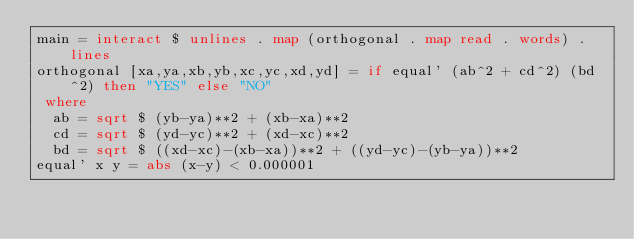Convert code to text. <code><loc_0><loc_0><loc_500><loc_500><_Haskell_>main = interact $ unlines . map (orthogonal . map read . words) . lines
orthogonal [xa,ya,xb,yb,xc,yc,xd,yd] = if equal' (ab^2 + cd^2) (bd^2) then "YES" else "NO"
 where
  ab = sqrt $ (yb-ya)**2 + (xb-xa)**2
  cd = sqrt $ (yd-yc)**2 + (xd-xc)**2
  bd = sqrt $ ((xd-xc)-(xb-xa))**2 + ((yd-yc)-(yb-ya))**2
equal' x y = abs (x-y) < 0.000001</code> 